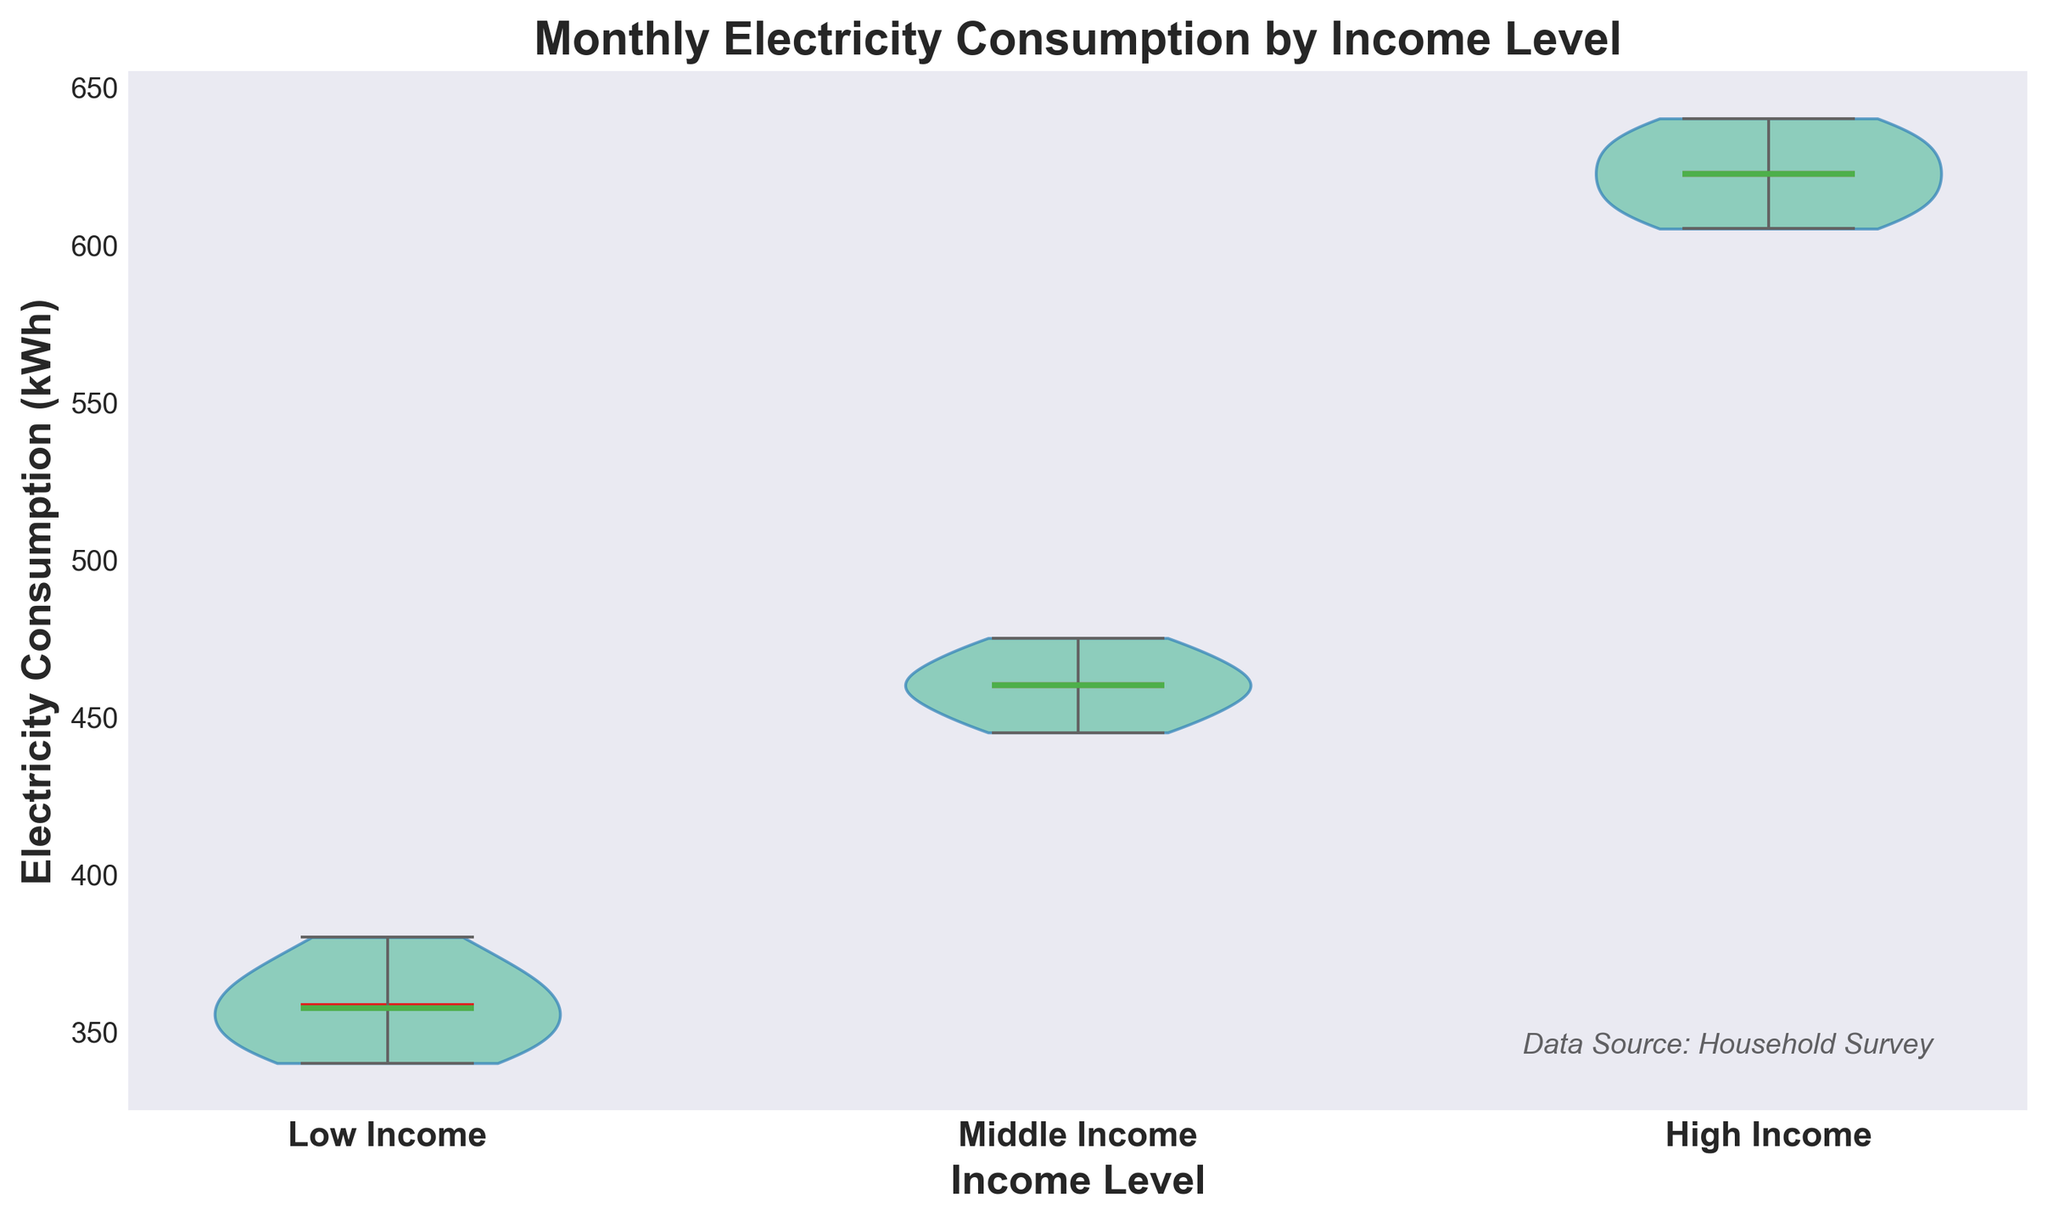What is the title of the figure? The title of the figure is displayed at the top of the plot. It is written in bold and slightly larger font than the other labels.
Answer: Monthly Electricity Consumption by Income Level What are the income levels shown on the x-axis? The x-axis displays different income levels mentioned as categories. By looking at the tick labels directly below the violin plots, we can identify them.
Answer: Low Income, Middle Income, High Income What is the median electricity consumption for the Middle Income group? The median for each group in a violin plot is represented by a horizontal line within the "violin" shape. For the Middle Income group, the line indicates the central value.
Answer: 460 kWh Compare the mean electricity consumption among the three income levels. Which group has the highest mean? The mean is shown as a line within the violin plot for each group, usually marked with a different color. By comparing the positions of these lines, the highest mean can be identified.
Answer: High Income What can be inferred about the distribution of electricity consumption for High Income households? The violin plot shows the distribution shape, where wider sections indicate more data points around those values. For High Income households, the shape is wider around the mean, suggesting more values are centered there. The narrow ends imply fewer extreme values.
Answer: More centralized around the mean Which income level shows the greatest range in electricity consumption? The range is indicated by the distance between the top and bottom whiskers in each violin plot. By comparing these lengths, we can determine the greatest range.
Answer: High Income Are there any visible outliers in the Low Income group's electricity consumption? Outliers in a violin plot, if any, are represented as individual points outside the whiskers. Checking the Low Income group's plot edge, we look for such points.
Answer: No What would be the effect on the figure if the High Income group's maximum value increased by 10 kWh? Increasing a value in the dataset would extend the top whisker, altering the range visualization for the High Income group. This new maximum point would push the upper edge of the violin plot further up.
Answer: Extended upper whisker Is the median electricity consumption higher or lower than the mean in the Middle Income group? The mean is represented by a line (usually marked differently) and the median by another line within the violin. By comparing the positions of these lines, we can deduce the relation.
Answer: They are equal Which income group shows the least variability in electricity consumption? Variability is indicated by the overall spread or width of the violin plots. A narrower plot suggests lower variability, with data points closer to each other.
Answer: Low Income 